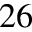<formula> <loc_0><loc_0><loc_500><loc_500>^ { 2 6 }</formula> 